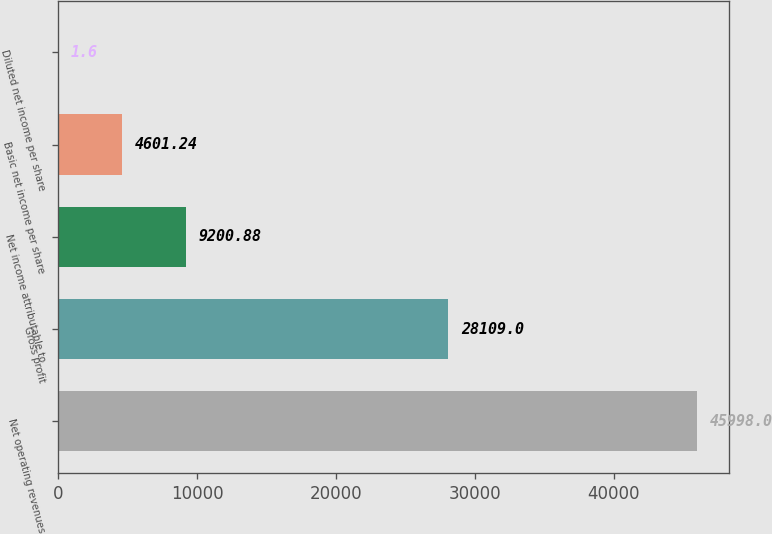Convert chart. <chart><loc_0><loc_0><loc_500><loc_500><bar_chart><fcel>Net operating revenues<fcel>Gross profit<fcel>Net income attributable to<fcel>Basic net income per share<fcel>Diluted net income per share<nl><fcel>45998<fcel>28109<fcel>9200.88<fcel>4601.24<fcel>1.6<nl></chart> 